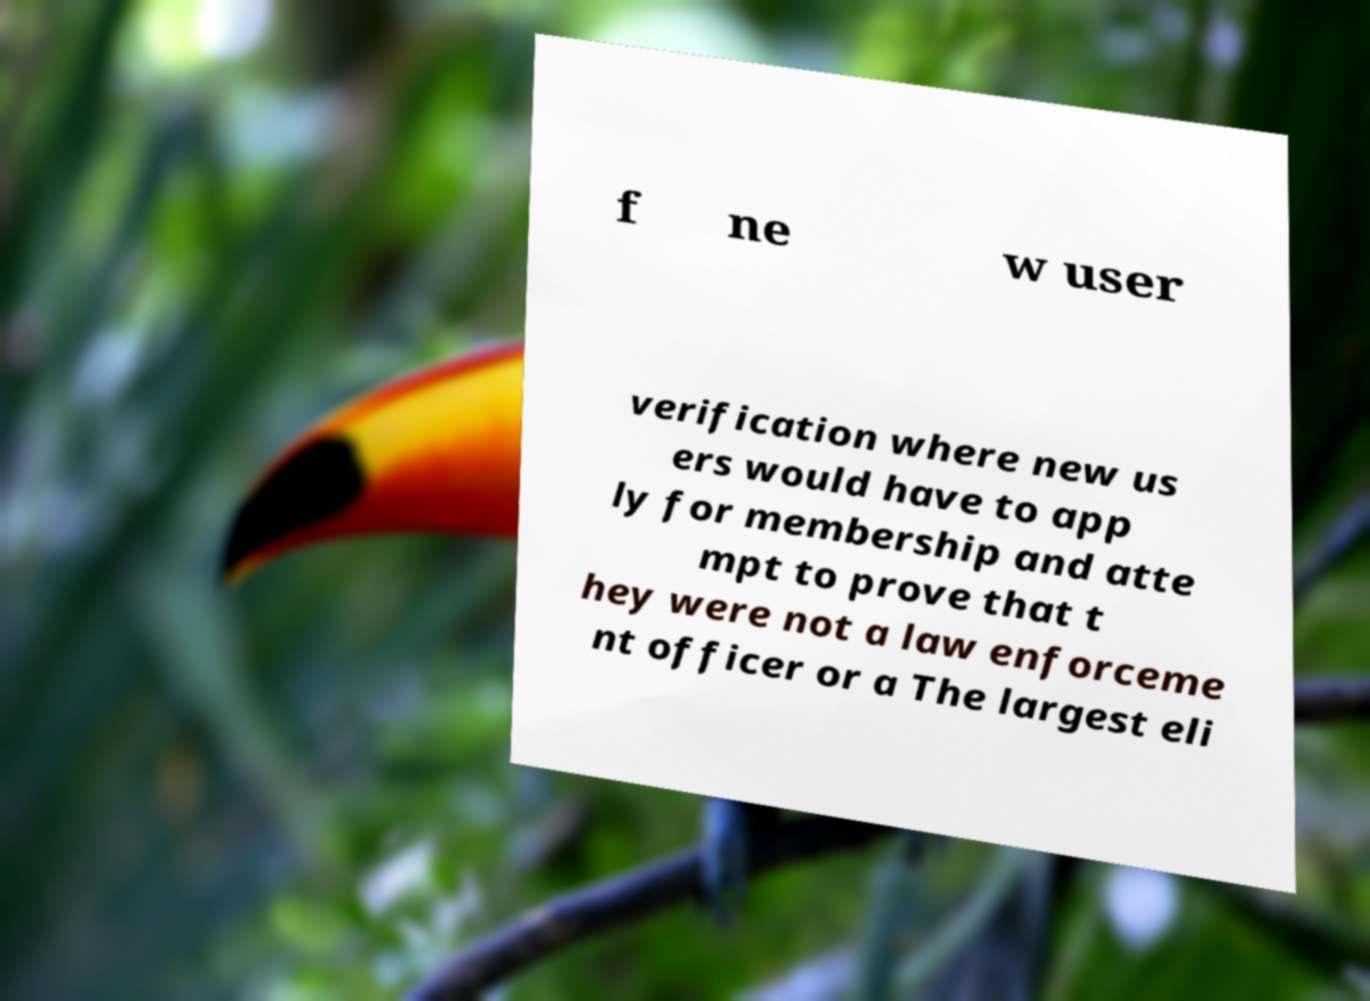Please read and relay the text visible in this image. What does it say? f ne w user verification where new us ers would have to app ly for membership and atte mpt to prove that t hey were not a law enforceme nt officer or a The largest eli 